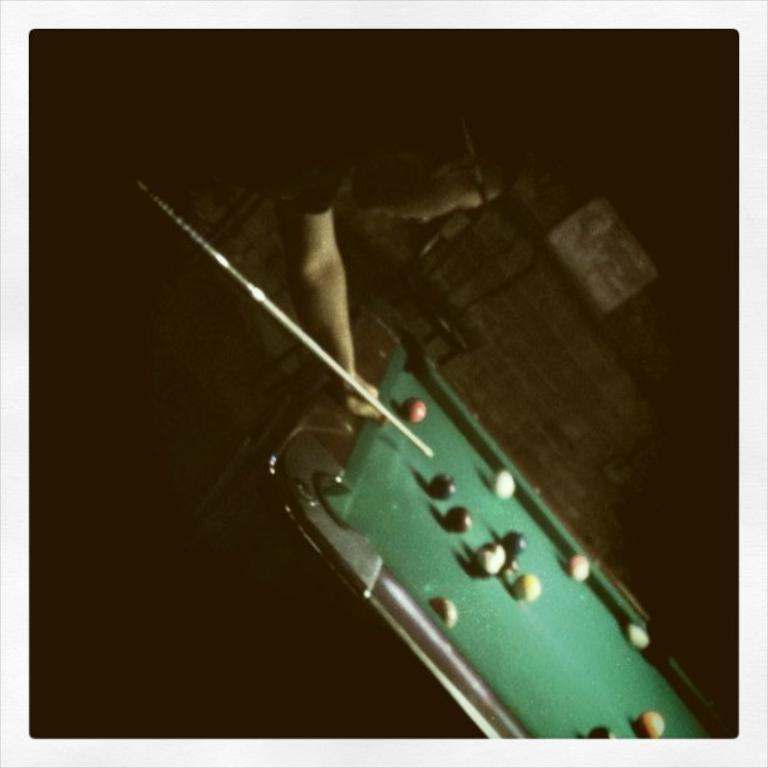Can you describe this image briefly? In this image, we can see a person holding a stick in his hand. On the right side, we can see a board, on that board there are some balls. In the background, we can see black color. 